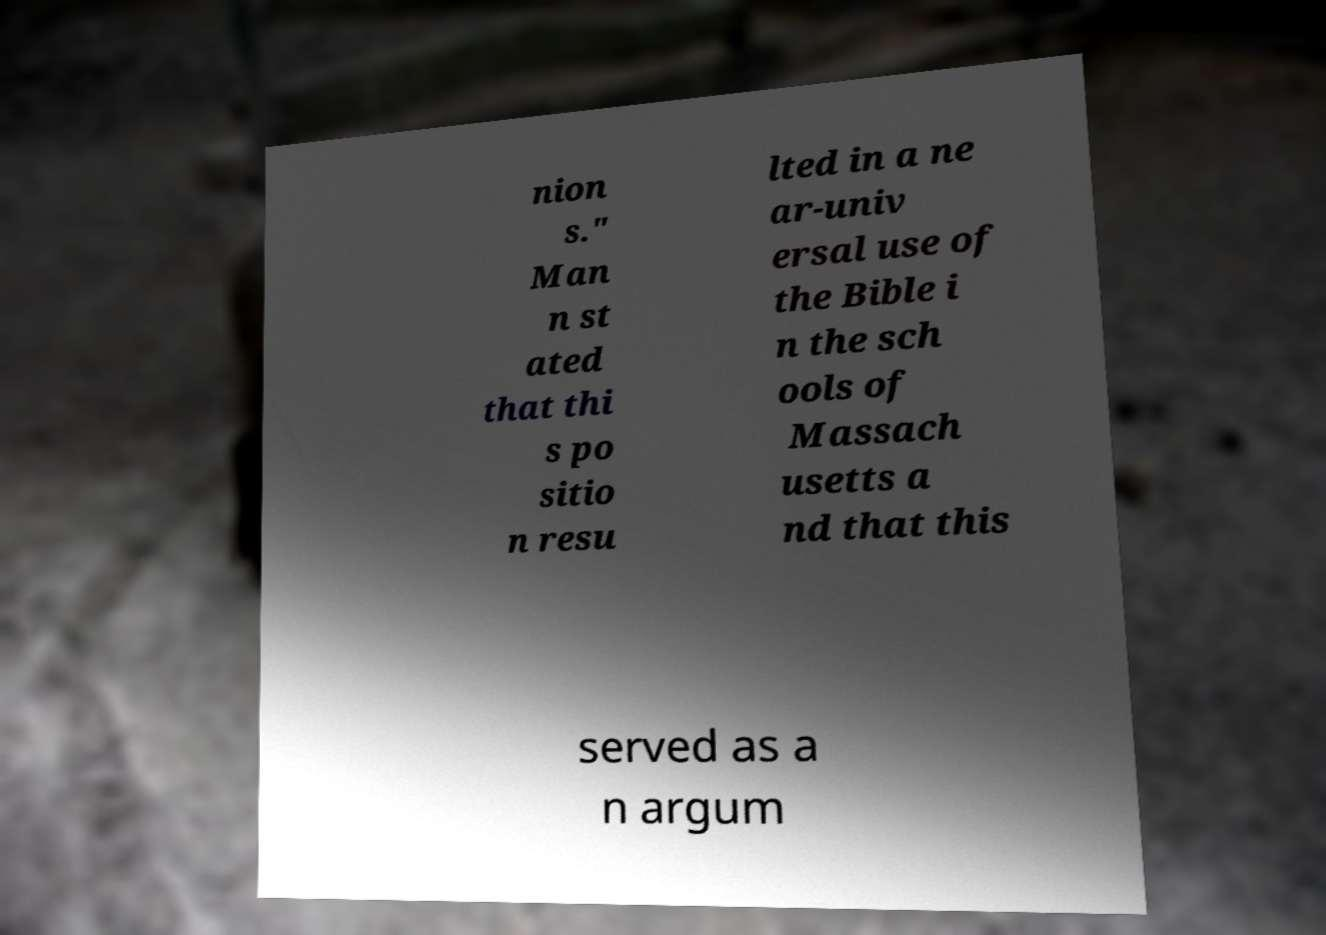Can you read and provide the text displayed in the image?This photo seems to have some interesting text. Can you extract and type it out for me? nion s." Man n st ated that thi s po sitio n resu lted in a ne ar-univ ersal use of the Bible i n the sch ools of Massach usetts a nd that this served as a n argum 